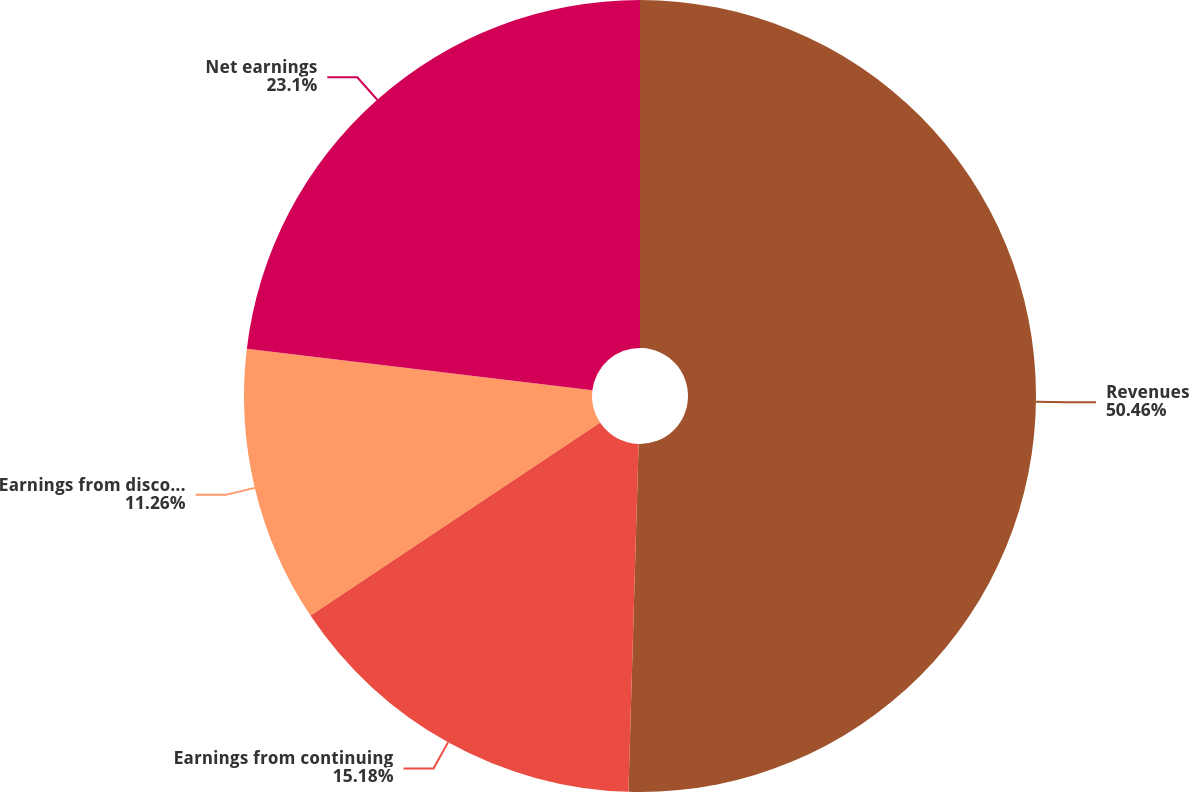Convert chart. <chart><loc_0><loc_0><loc_500><loc_500><pie_chart><fcel>Revenues<fcel>Earnings from continuing<fcel>Earnings from discontinued<fcel>Net earnings<nl><fcel>50.47%<fcel>15.18%<fcel>11.26%<fcel>23.1%<nl></chart> 